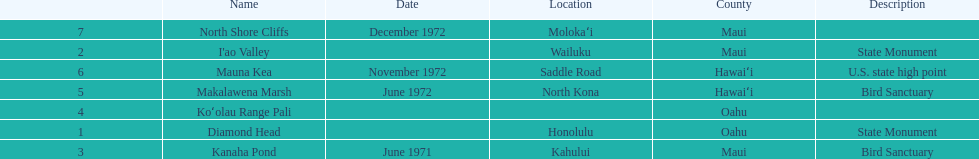How many names do not have a description? 2. 